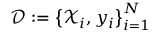Convert formula to latex. <formula><loc_0><loc_0><loc_500><loc_500>\mathcal { D } \colon = \left \{ \mathcal { X } _ { i } , y _ { i } \right \} _ { i = 1 } ^ { N }</formula> 